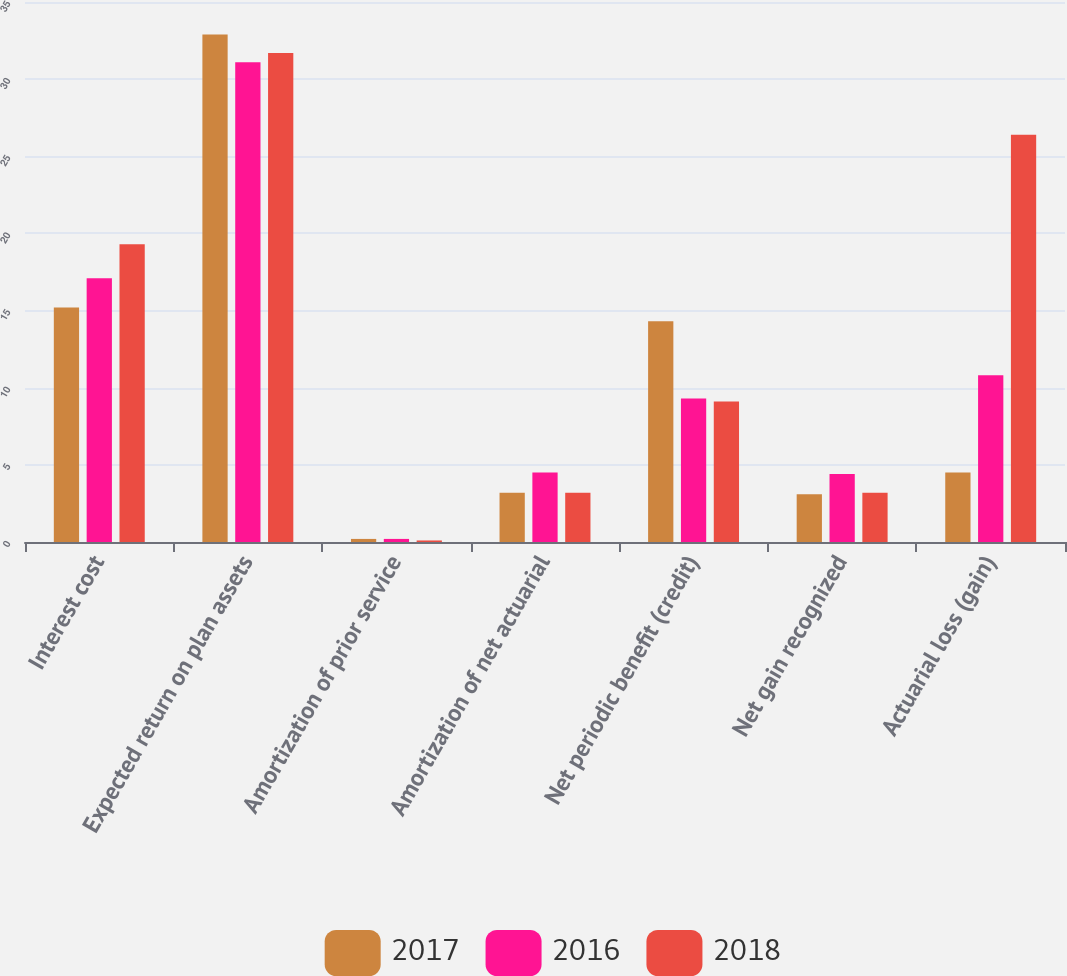Convert chart to OTSL. <chart><loc_0><loc_0><loc_500><loc_500><stacked_bar_chart><ecel><fcel>Interest cost<fcel>Expected return on plan assets<fcel>Amortization of prior service<fcel>Amortization of net actuarial<fcel>Net periodic benefit (credit)<fcel>Net gain recognized<fcel>Actuarial loss (gain)<nl><fcel>2017<fcel>15.2<fcel>32.9<fcel>0.2<fcel>3.2<fcel>14.3<fcel>3.1<fcel>4.5<nl><fcel>2016<fcel>17.1<fcel>31.1<fcel>0.2<fcel>4.5<fcel>9.3<fcel>4.4<fcel>10.8<nl><fcel>2018<fcel>19.3<fcel>31.7<fcel>0.1<fcel>3.2<fcel>9.1<fcel>3.2<fcel>26.4<nl></chart> 